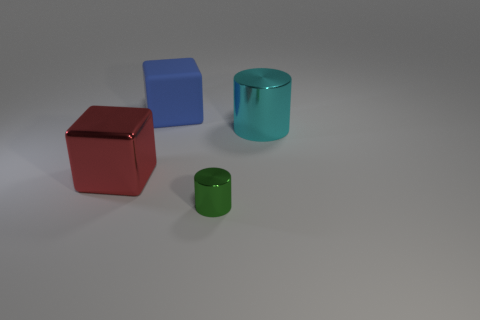Add 3 big cyan rubber cylinders. How many objects exist? 7 Add 4 large purple balls. How many large purple balls exist? 4 Subtract 0 purple blocks. How many objects are left? 4 Subtract all large blue shiny objects. Subtract all big blocks. How many objects are left? 2 Add 2 blocks. How many blocks are left? 4 